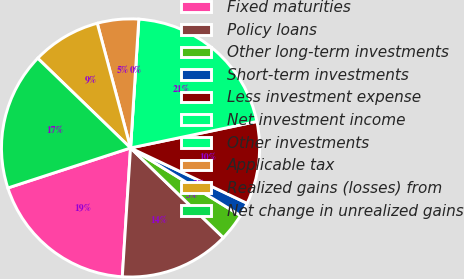<chart> <loc_0><loc_0><loc_500><loc_500><pie_chart><fcel>Fixed maturities<fcel>Policy loans<fcel>Other long-term investments<fcel>Short-term investments<fcel>Less investment expense<fcel>Net investment income<fcel>Other investments<fcel>Applicable tax<fcel>Realized gains (losses) from<fcel>Net change in unrealized gains<nl><fcel>18.96%<fcel>13.79%<fcel>3.45%<fcel>1.72%<fcel>10.34%<fcel>20.69%<fcel>0.0%<fcel>5.17%<fcel>8.62%<fcel>17.24%<nl></chart> 